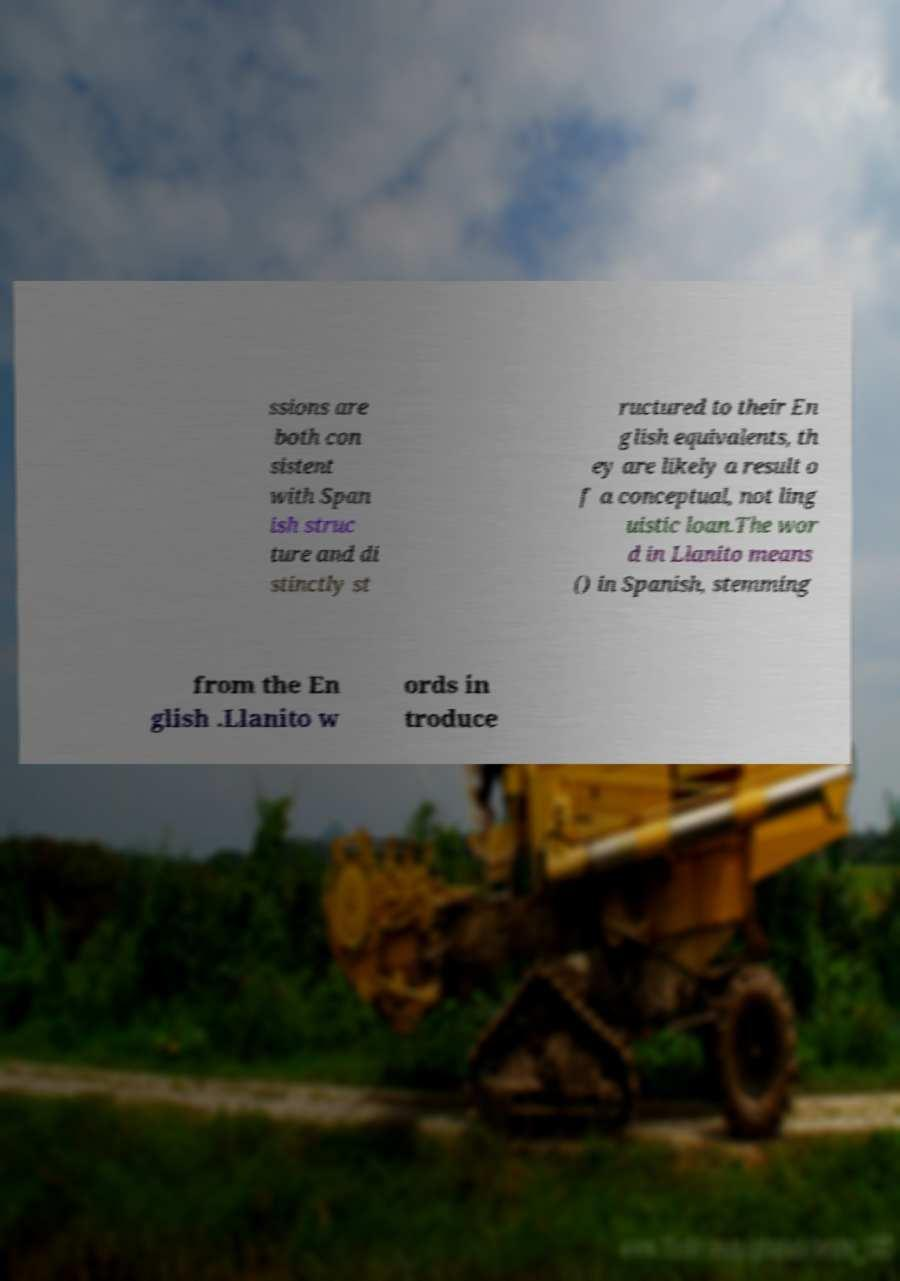For documentation purposes, I need the text within this image transcribed. Could you provide that? ssions are both con sistent with Span ish struc ture and di stinctly st ructured to their En glish equivalents, th ey are likely a result o f a conceptual, not ling uistic loan.The wor d in Llanito means () in Spanish, stemming from the En glish .Llanito w ords in troduce 